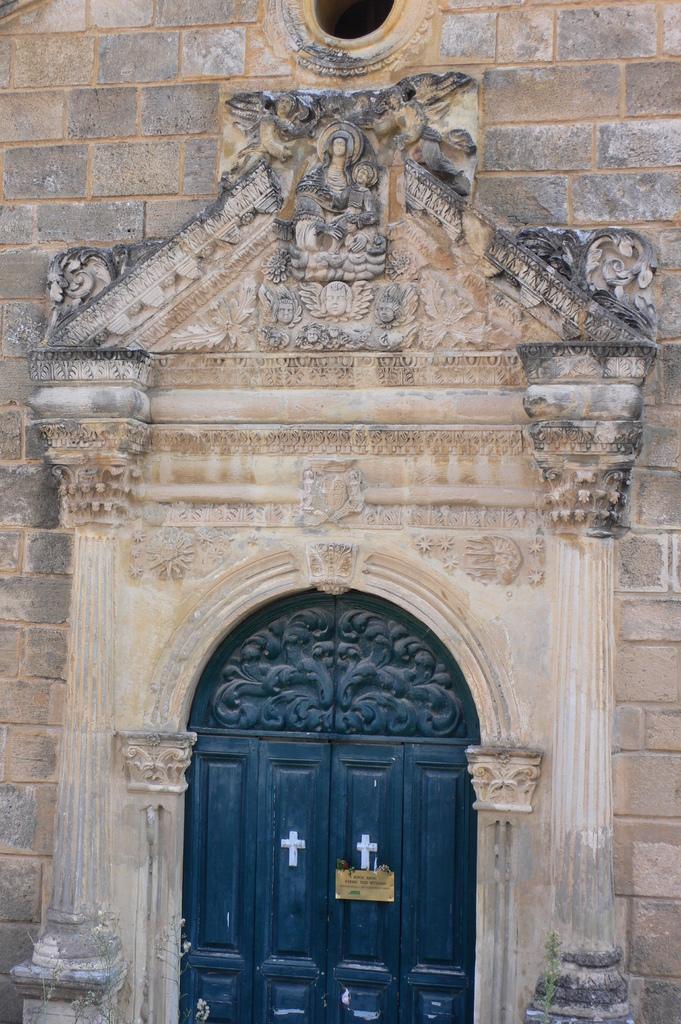Please provide a concise description of this image. The picture consists of a church wall. At the bottom there is door. In the middle we can see sculptures. 